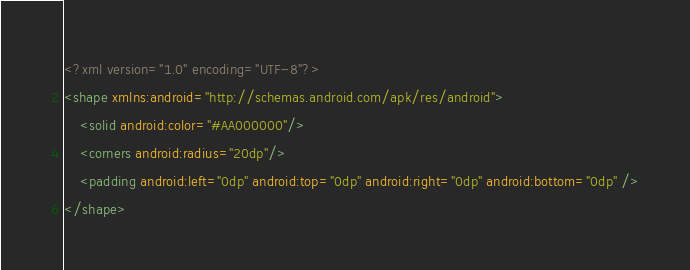Convert code to text. <code><loc_0><loc_0><loc_500><loc_500><_XML_><?xml version="1.0" encoding="UTF-8"?>
<shape xmlns:android="http://schemas.android.com/apk/res/android">
    <solid android:color="#AA000000"/>
    <corners android:radius="20dp"/>
    <padding android:left="0dp" android:top="0dp" android:right="0dp" android:bottom="0dp" />
</shape></code> 